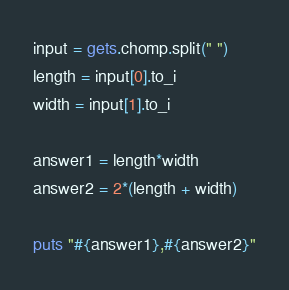Convert code to text. <code><loc_0><loc_0><loc_500><loc_500><_Ruby_>input = gets.chomp.split(" ")
length = input[0].to_i
width = input[1].to_i

answer1 = length*width
answer2 = 2*(length + width)

puts "#{answer1},#{answer2}"
</code> 